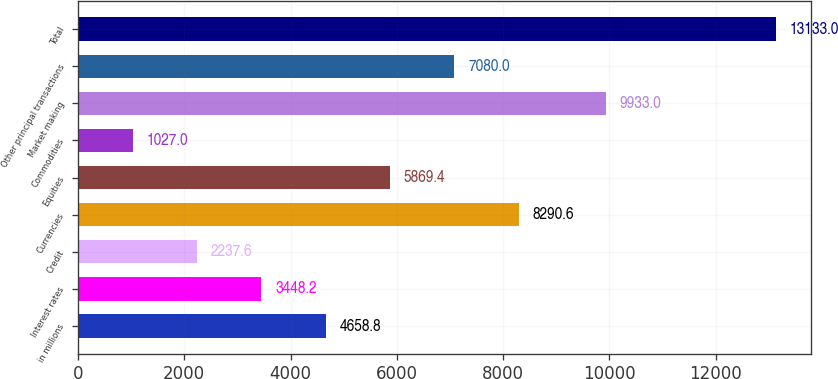Convert chart. <chart><loc_0><loc_0><loc_500><loc_500><bar_chart><fcel>in millions<fcel>Interest rates<fcel>Credit<fcel>Currencies<fcel>Equities<fcel>Commodities<fcel>Market making<fcel>Other principal transactions<fcel>Total<nl><fcel>4658.8<fcel>3448.2<fcel>2237.6<fcel>8290.6<fcel>5869.4<fcel>1027<fcel>9933<fcel>7080<fcel>13133<nl></chart> 